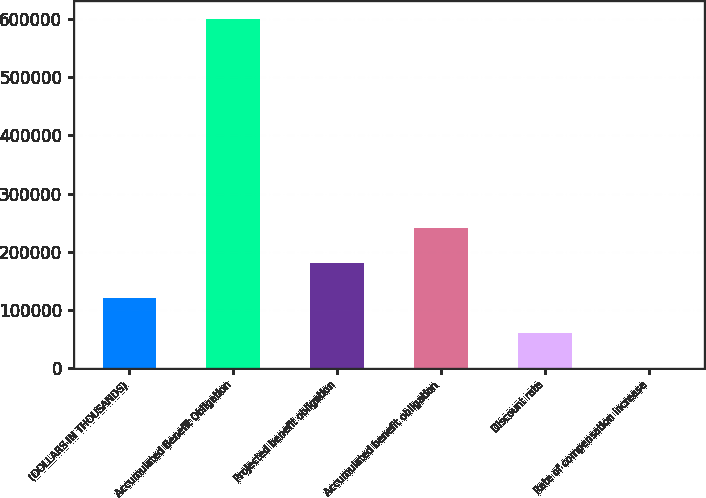Convert chart. <chart><loc_0><loc_0><loc_500><loc_500><bar_chart><fcel>(DOLLARS IN THOUSANDS)<fcel>Accumulated Benefit Obligation<fcel>Projected benefit obligation<fcel>Accumulated benefit obligation<fcel>Discount rate<fcel>Rate of compensation increase<nl><fcel>120129<fcel>600634<fcel>180192<fcel>240256<fcel>60066.3<fcel>3.25<nl></chart> 